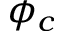<formula> <loc_0><loc_0><loc_500><loc_500>\phi _ { c }</formula> 